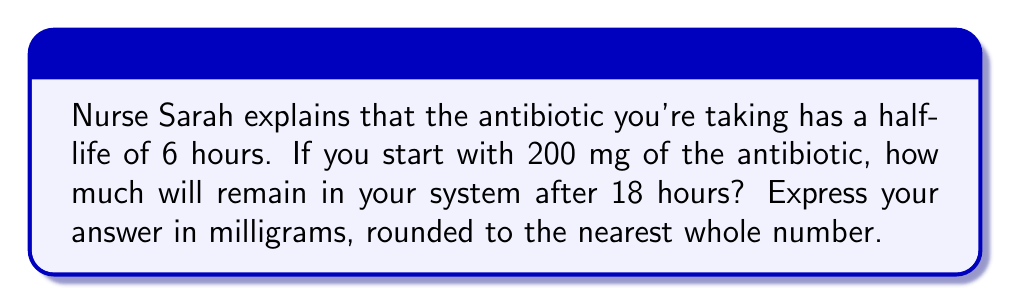Give your solution to this math problem. Let's approach this step-by-step:

1) The half-life of a substance is the time it takes for half of it to decay. In this case, the half-life is 6 hours.

2) We need to determine how many half-lives have passed in 18 hours:
   $\frac{18 \text{ hours}}{6 \text{ hours per half-life}} = 3 \text{ half-lives}$

3) Now, we can use the exponential decay formula:
   $A(t) = A_0 \cdot (\frac{1}{2})^n$
   
   Where:
   $A(t)$ is the amount remaining after time $t$
   $A_0$ is the initial amount
   $n$ is the number of half-lives

4) Plugging in our values:
   $A(18) = 200 \cdot (\frac{1}{2})^3$

5) Let's calculate this:
   $A(18) = 200 \cdot \frac{1}{8} = 25$

6) Therefore, after 18 hours, 25 mg of the antibiotic will remain in your system.
Answer: 25 mg 